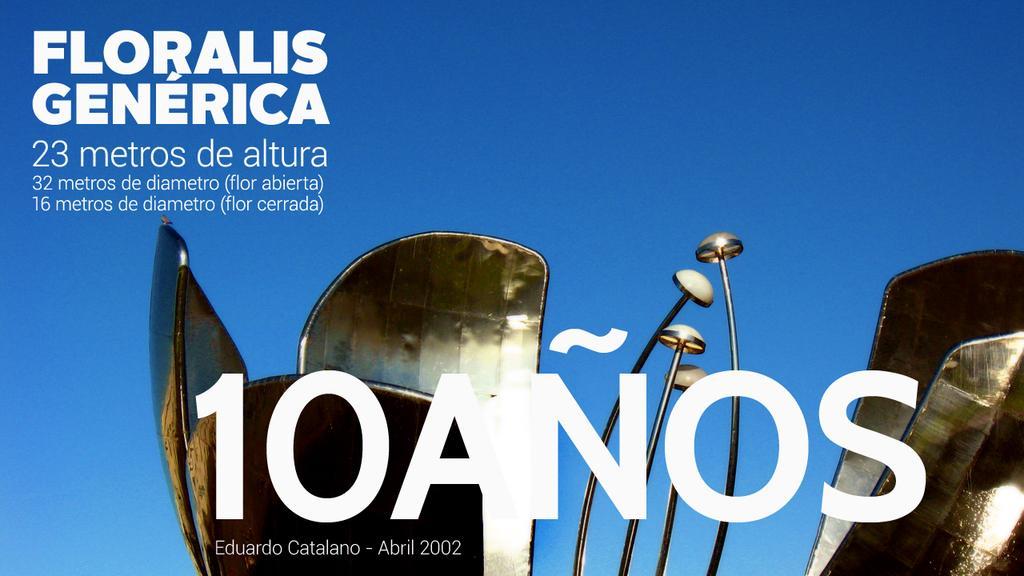How would you summarize this image in a sentence or two? This looks like a poster. I think this is a metal object, which looks like a flower. I can see the letters and numbers on the poster. The background looks blue in color. 